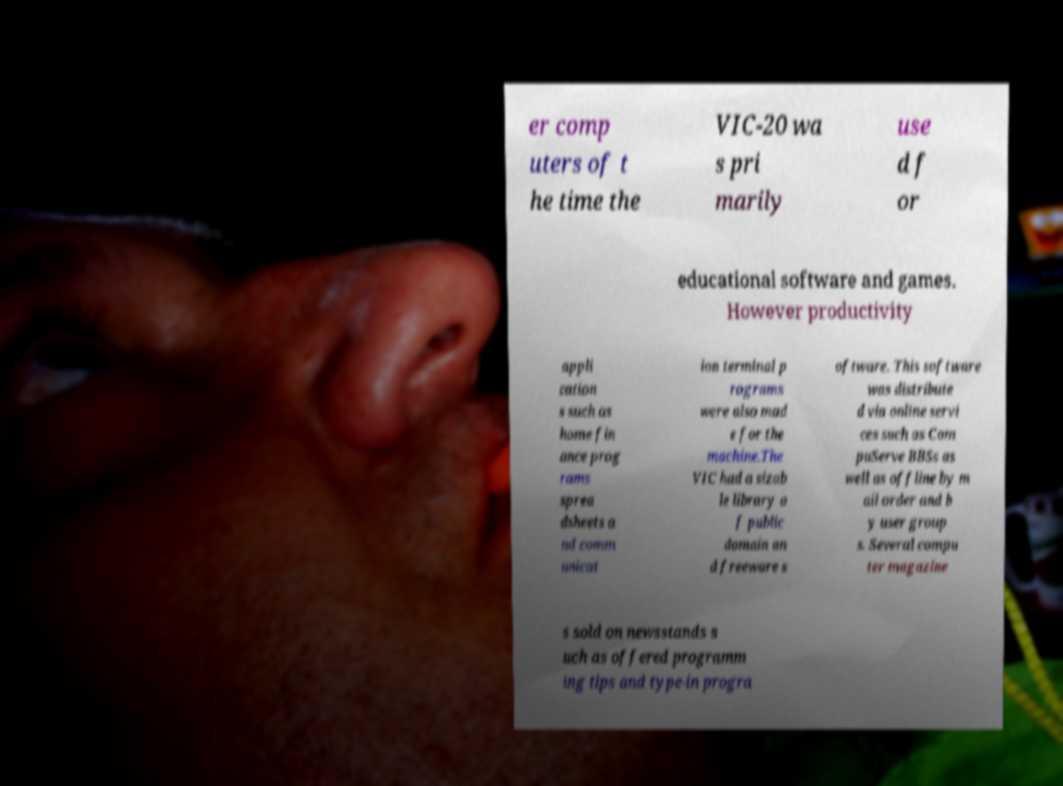I need the written content from this picture converted into text. Can you do that? er comp uters of t he time the VIC-20 wa s pri marily use d f or educational software and games. However productivity appli cation s such as home fin ance prog rams sprea dsheets a nd comm unicat ion terminal p rograms were also mad e for the machine.The VIC had a sizab le library o f public domain an d freeware s oftware. This software was distribute d via online servi ces such as Com puServe BBSs as well as offline by m ail order and b y user group s. Several compu ter magazine s sold on newsstands s uch as offered programm ing tips and type-in progra 